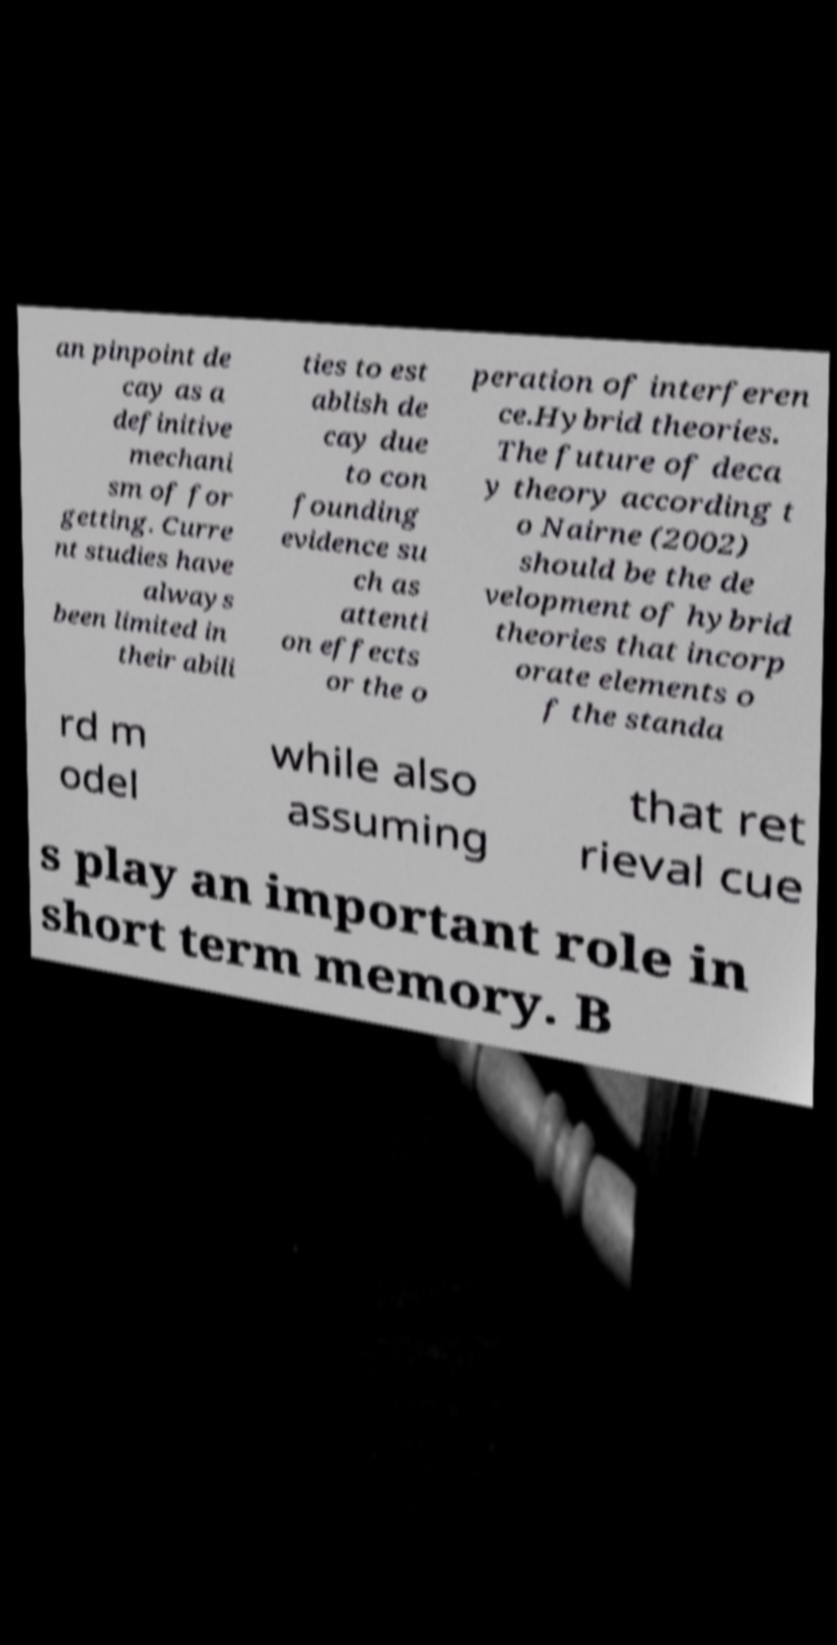I need the written content from this picture converted into text. Can you do that? an pinpoint de cay as a definitive mechani sm of for getting. Curre nt studies have always been limited in their abili ties to est ablish de cay due to con founding evidence su ch as attenti on effects or the o peration of interferen ce.Hybrid theories. The future of deca y theory according t o Nairne (2002) should be the de velopment of hybrid theories that incorp orate elements o f the standa rd m odel while also assuming that ret rieval cue s play an important role in short term memory. B 